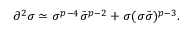Convert formula to latex. <formula><loc_0><loc_0><loc_500><loc_500>\partial ^ { 2 } \sigma \simeq \sigma ^ { p - 4 } \bar { \sigma } ^ { p - 2 } + \sigma ( \sigma \bar { \sigma } ) ^ { p - 3 } .</formula> 